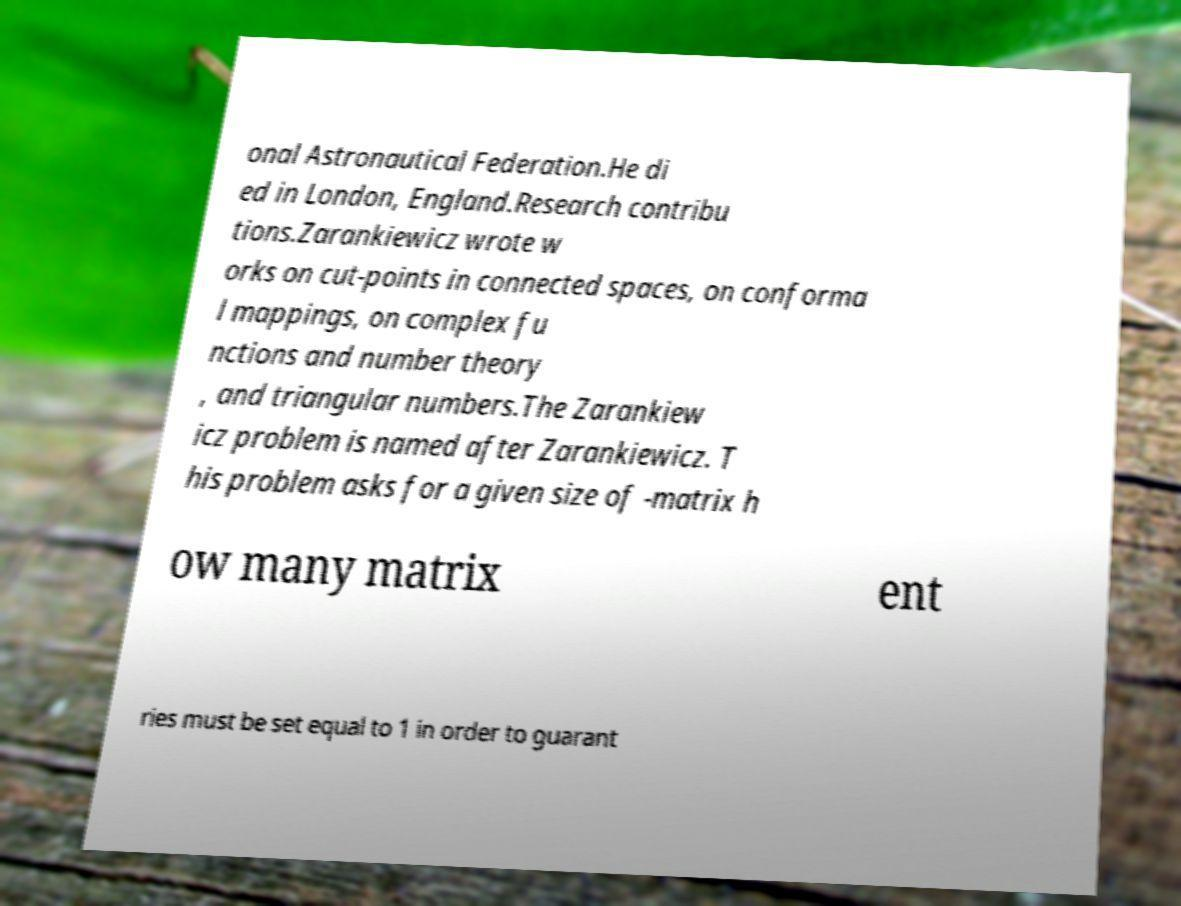Can you accurately transcribe the text from the provided image for me? onal Astronautical Federation.He di ed in London, England.Research contribu tions.Zarankiewicz wrote w orks on cut-points in connected spaces, on conforma l mappings, on complex fu nctions and number theory , and triangular numbers.The Zarankiew icz problem is named after Zarankiewicz. T his problem asks for a given size of -matrix h ow many matrix ent ries must be set equal to 1 in order to guarant 